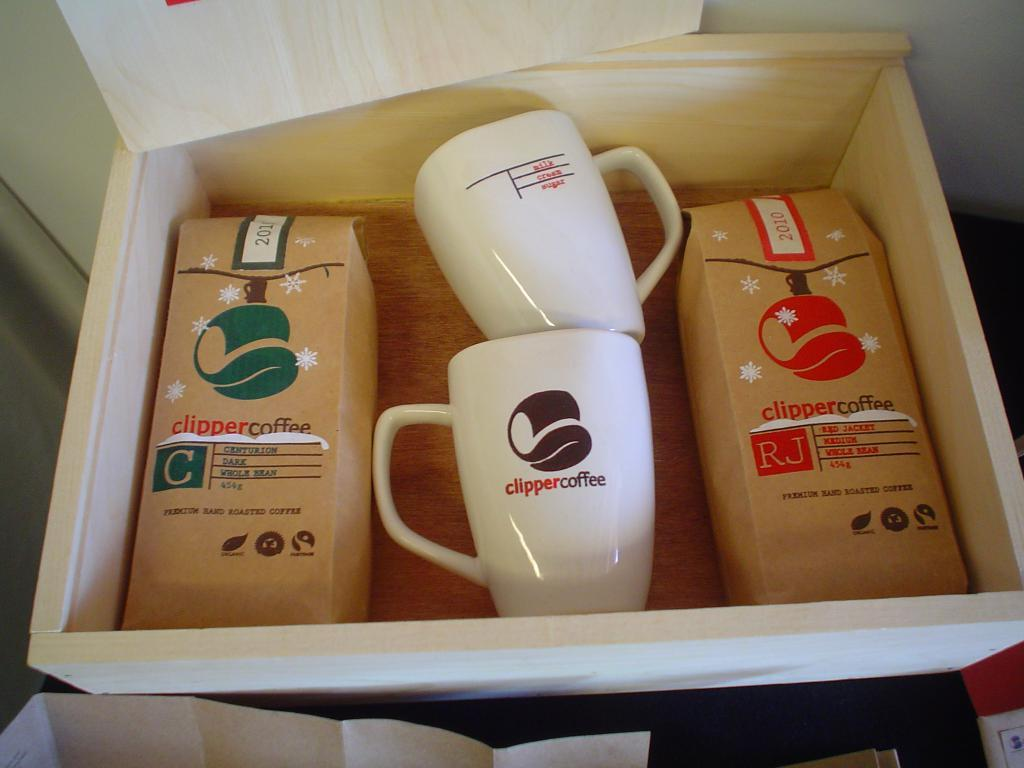<image>
Render a clear and concise summary of the photo. a wood box of clipper coffee and mugs 